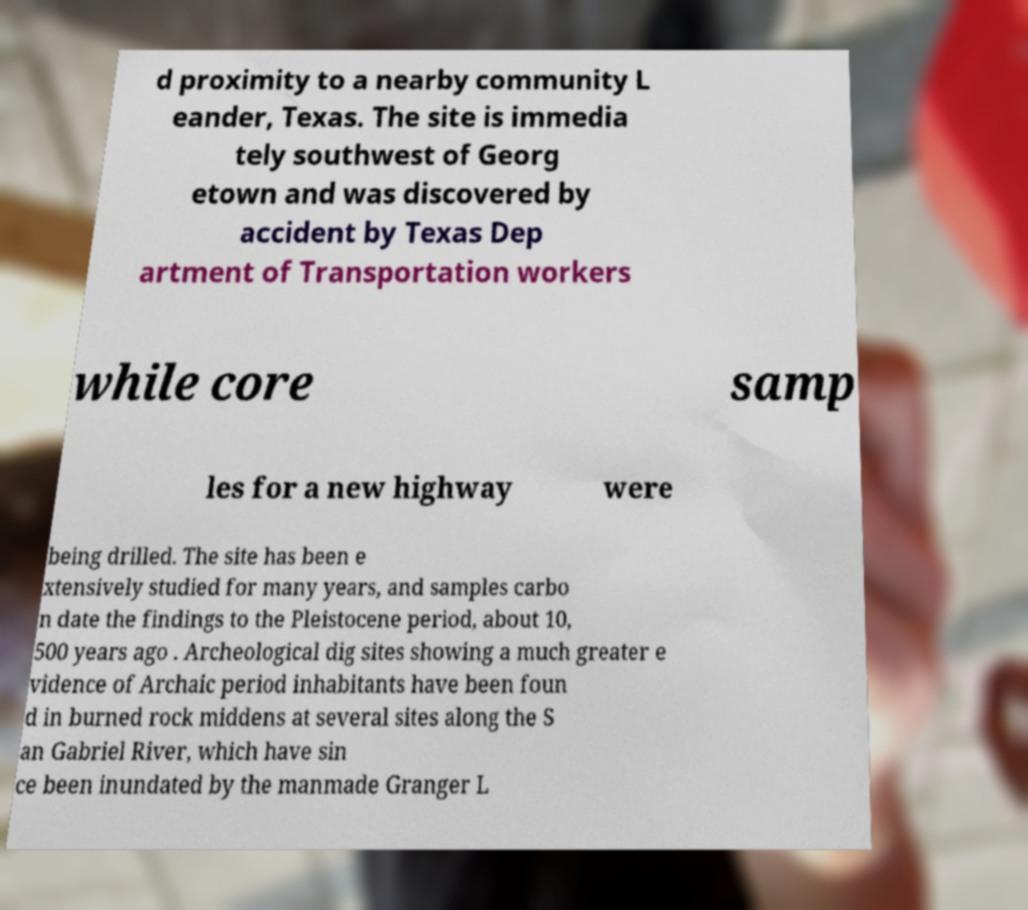I need the written content from this picture converted into text. Can you do that? d proximity to a nearby community L eander, Texas. The site is immedia tely southwest of Georg etown and was discovered by accident by Texas Dep artment of Transportation workers while core samp les for a new highway were being drilled. The site has been e xtensively studied for many years, and samples carbo n date the findings to the Pleistocene period, about 10, 500 years ago . Archeological dig sites showing a much greater e vidence of Archaic period inhabitants have been foun d in burned rock middens at several sites along the S an Gabriel River, which have sin ce been inundated by the manmade Granger L 